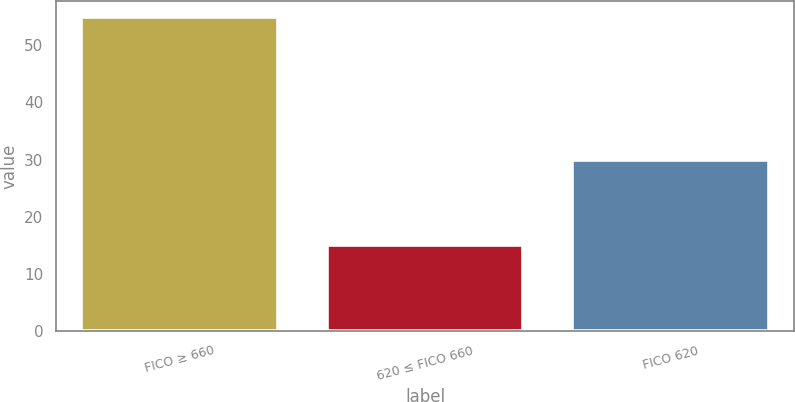<chart> <loc_0><loc_0><loc_500><loc_500><bar_chart><fcel>FICO ≥ 660<fcel>620 ≤ FICO 660<fcel>FICO 620<nl><fcel>55<fcel>15<fcel>30<nl></chart> 